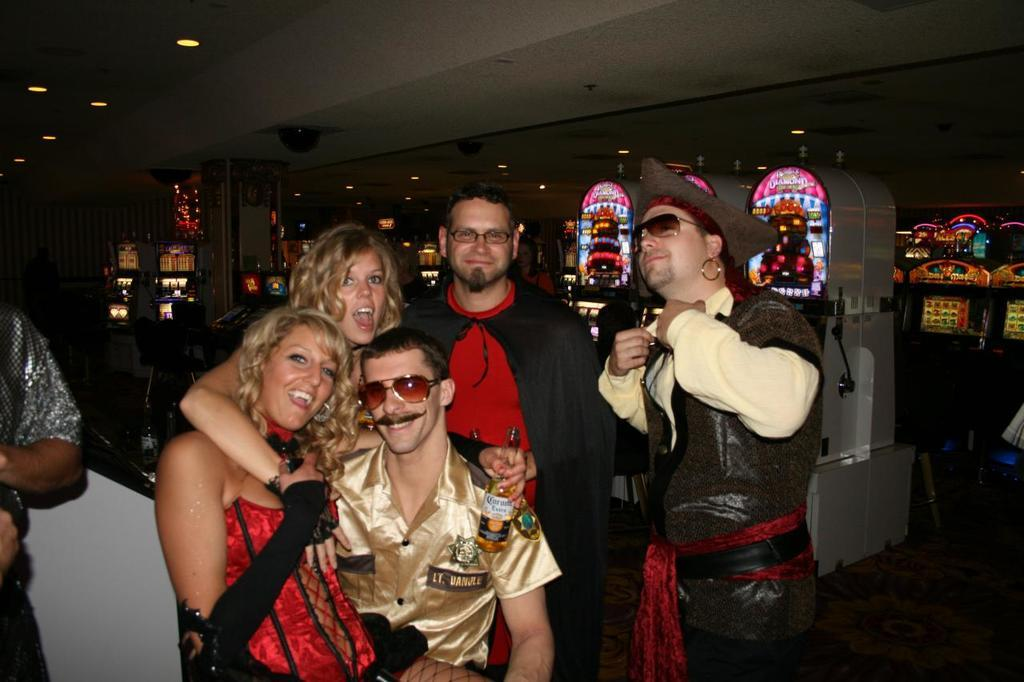How many people are in the image? There are people in the image, but the exact number is not specified. What is the facial expression of some people in the image? Some people in the image are smiling. What are some people holding in the image? Some people are holding objects in the image. What can be seen in the background of the image? There is a chair and a wall in the background of the image. What is visible at the top of the image? There is a roof with lights visible at the top of the image. What type of arch can be seen in the image? There is no arch present in the image. Can you tell me how many bats are flying in the image? There are no bats visible in the image. 